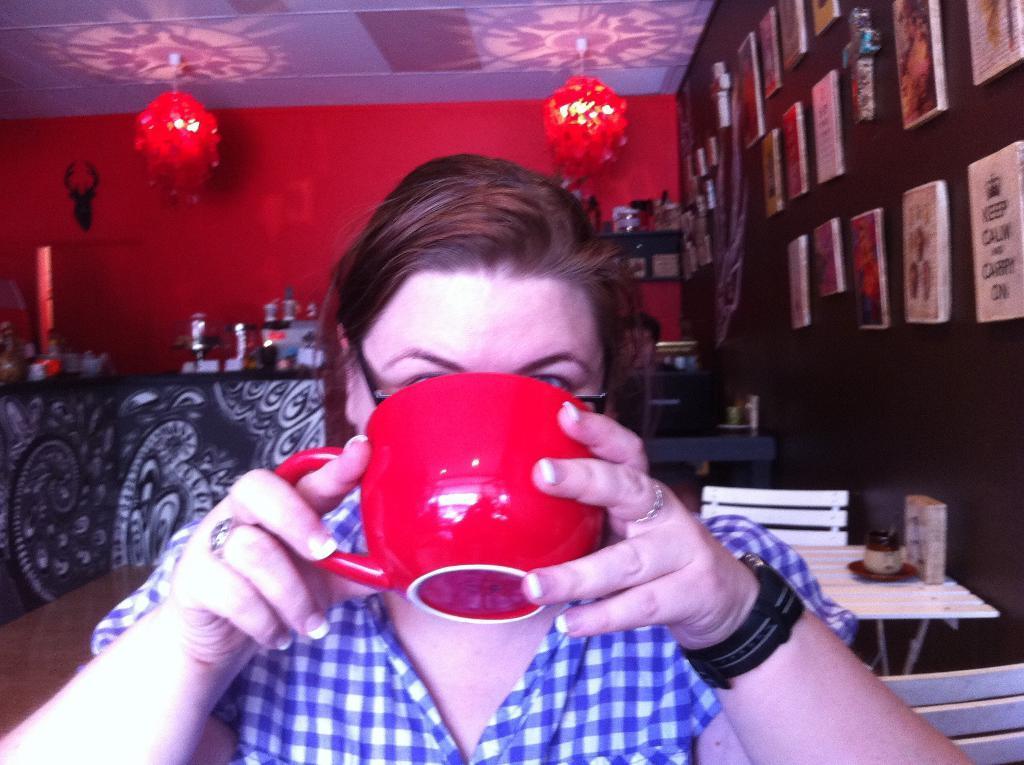How would you summarize this image in a sentence or two? In this image in the foreground there is one woman who is holding a cup, and she is drinking and in the background there are tables, chairs and some objects. And on the left side of the image there is a table, on the table there are some objects. And on the right side there are some frames on the wall, in the background there is a wall and some lights and some objects. At the top there is ceiling and lights. 